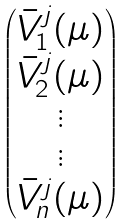Convert formula to latex. <formula><loc_0><loc_0><loc_500><loc_500>\begin{pmatrix} { \bar { V } ^ { j } } _ { 1 } ( \mu ) \\ { \bar { V } ^ { j } } _ { 2 } ( \mu ) \\ \vdots \\ \vdots \\ { \bar { V } ^ { j } } _ { n } ( \mu ) \end{pmatrix}</formula> 